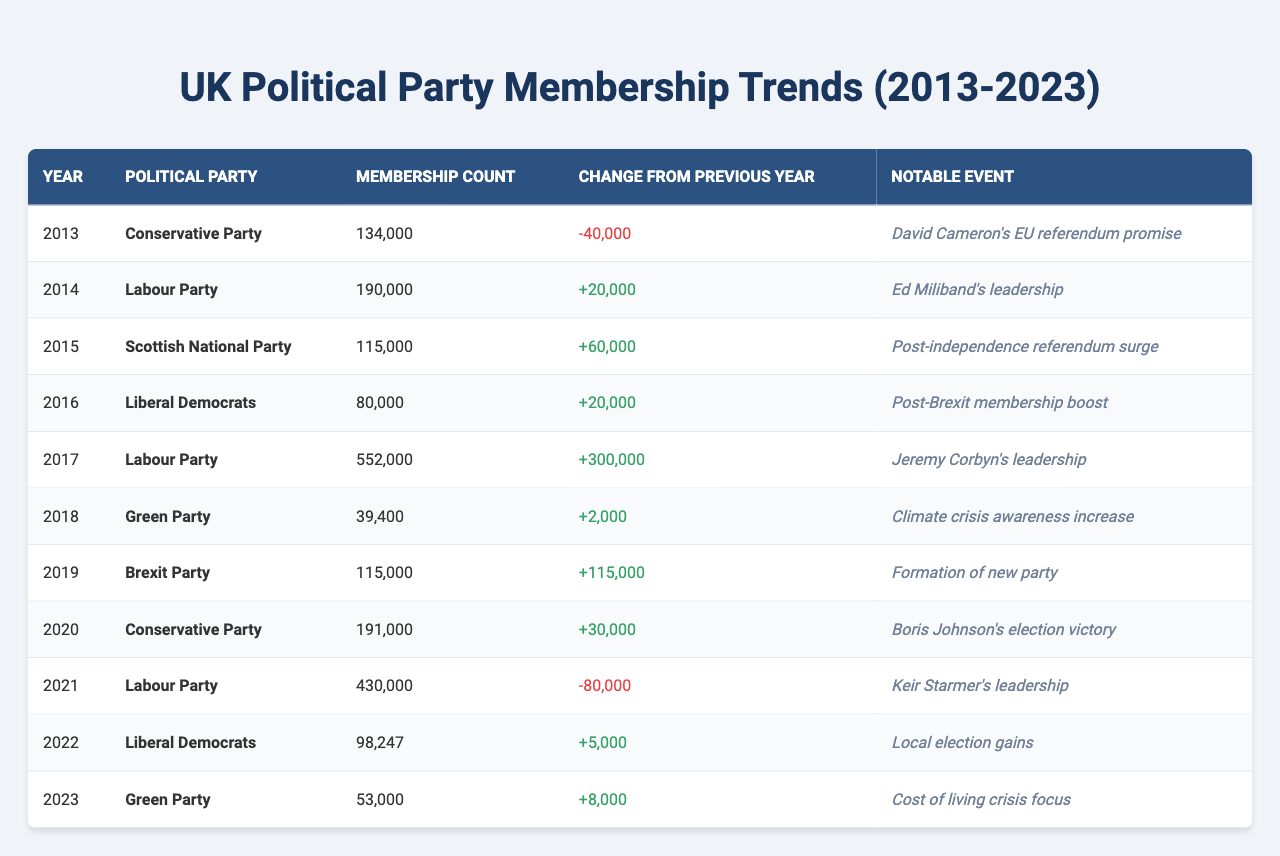What was the membership count of the Labour Party in 2017? The table states that the Labour Party had a membership count of 552,000 in 2017.
Answer: 552,000 What notable event is associated with the Conservative Party's membership change in 2014? The table indicates that David Cameron's EU referendum promise is the notable event associated with the Conservative Party in that year.
Answer: David Cameron's EU referendum promise Which political party saw the largest increase in membership from 2018 to 2019? To find the answer, compare the membership counts: 39,400 for the Green Party in 2018 and 115,000 for the Brexit Party in 2019. Therefore, the Brexit Party has the largest increase of 115,000.
Answer: Brexit Party What is the total membership count of the Green Party across the years listed in the table? The membership counts of the Green Party are 39,400 in 2018 and 53,000 in 2023. Adding these gives 39,400 + 53,000 = 92,400.
Answer: 92,400 Did the Liberal Democrats experience an increase in membership in 2021? In 2021, the table indicates a membership count of 98,247 and a change from the previous year of 5,000. Since the change is positive, it confirms an increase.
Answer: Yes Which year saw the lowest membership count for the Conservative Party in this table? From the table, the lowest membership count for the Conservative Party was 134,000 in 2013.
Answer: 2013 What was the membership change for the Labour Party between 2017 and 2021? The Labour Party had a membership count of 552,000 in 2017 and 430,000 in 2021. Thus, the change is 430,000 - 552,000 = -122,000.
Answer: -122,000 Which party gained membership due to a local election gain in 2022? According to the table, the Liberal Democrats gained membership in 2022 attributed to local election gains.
Answer: Liberal Democrats How many total membership changes were positive from 2013 to 2023? Examining the change values: 20,000 (Labour 2014), 60,000 (SNP 2015), 20,000 (Liberal Democrats 2016), 300,000 (Labour 2017), 115,000 (Brexit Party 2019), 30,000 (Conservative 2020), 5,000 (Liberal Democrats 2022), and 8,000 (Green Party 2023), gives a total of 8 positive changes in these years.
Answer: 8 What was the trend for the Conservative Party's membership from 2013 to 2020? The table indicates a decline to 134,000 in 2013, then a drop to 91,000 in 2014, a rise to 191,000 in 2020, indicating fluctuations with an overall increase by 2020.
Answer: Fluctuating with overall increase by 2020 Which year featured the highest membership count across all parties mentioned? The Labour Party had the highest membership count of 552,000 in 2017, which is higher than any other party in the table.
Answer: 2017 